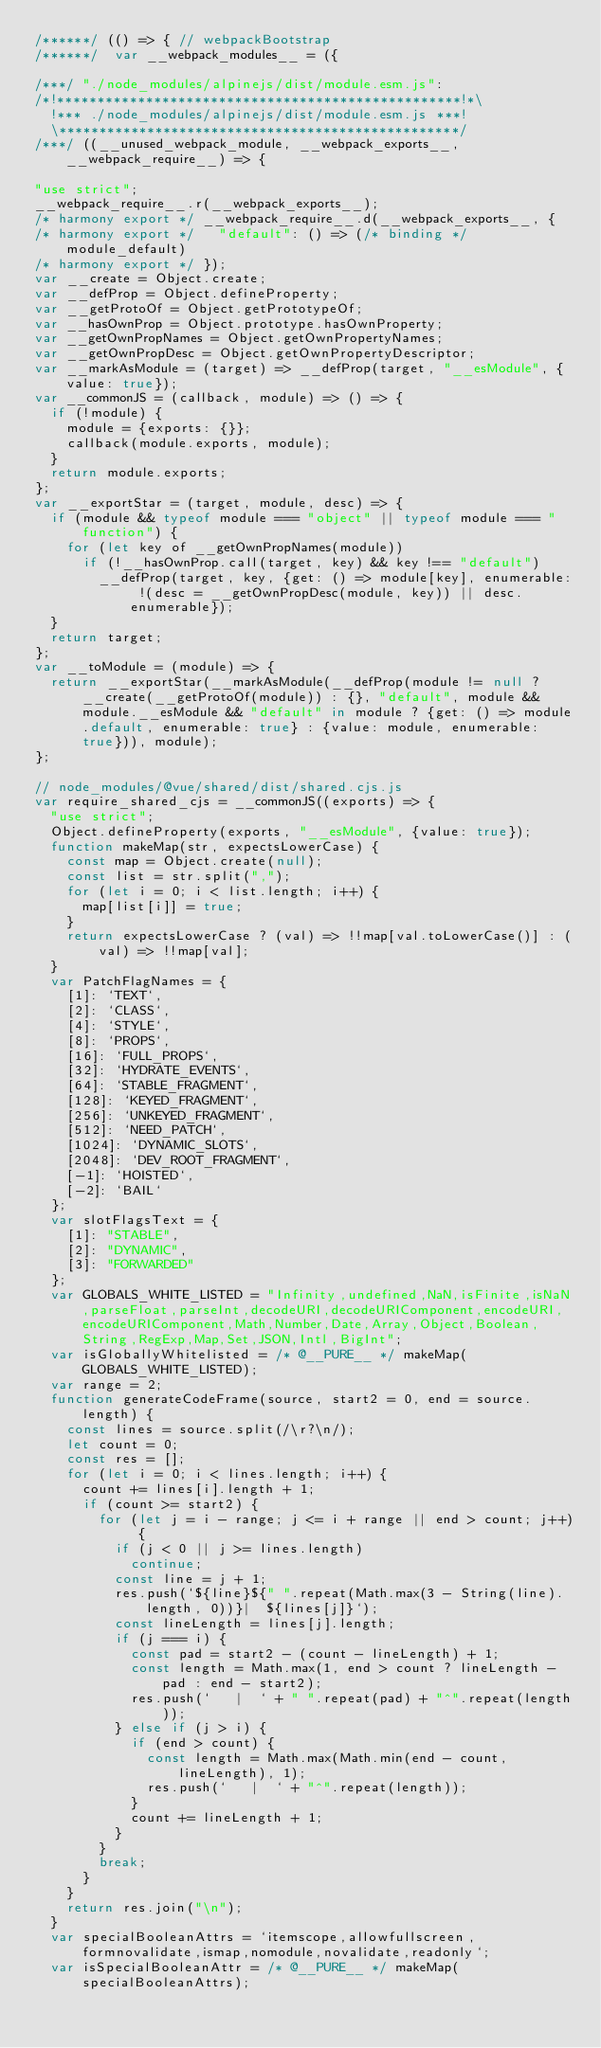Convert code to text. <code><loc_0><loc_0><loc_500><loc_500><_JavaScript_>/******/ (() => { // webpackBootstrap
/******/ 	var __webpack_modules__ = ({

/***/ "./node_modules/alpinejs/dist/module.esm.js":
/*!**************************************************!*\
  !*** ./node_modules/alpinejs/dist/module.esm.js ***!
  \**************************************************/
/***/ ((__unused_webpack_module, __webpack_exports__, __webpack_require__) => {

"use strict";
__webpack_require__.r(__webpack_exports__);
/* harmony export */ __webpack_require__.d(__webpack_exports__, {
/* harmony export */   "default": () => (/* binding */ module_default)
/* harmony export */ });
var __create = Object.create;
var __defProp = Object.defineProperty;
var __getProtoOf = Object.getPrototypeOf;
var __hasOwnProp = Object.prototype.hasOwnProperty;
var __getOwnPropNames = Object.getOwnPropertyNames;
var __getOwnPropDesc = Object.getOwnPropertyDescriptor;
var __markAsModule = (target) => __defProp(target, "__esModule", {value: true});
var __commonJS = (callback, module) => () => {
  if (!module) {
    module = {exports: {}};
    callback(module.exports, module);
  }
  return module.exports;
};
var __exportStar = (target, module, desc) => {
  if (module && typeof module === "object" || typeof module === "function") {
    for (let key of __getOwnPropNames(module))
      if (!__hasOwnProp.call(target, key) && key !== "default")
        __defProp(target, key, {get: () => module[key], enumerable: !(desc = __getOwnPropDesc(module, key)) || desc.enumerable});
  }
  return target;
};
var __toModule = (module) => {
  return __exportStar(__markAsModule(__defProp(module != null ? __create(__getProtoOf(module)) : {}, "default", module && module.__esModule && "default" in module ? {get: () => module.default, enumerable: true} : {value: module, enumerable: true})), module);
};

// node_modules/@vue/shared/dist/shared.cjs.js
var require_shared_cjs = __commonJS((exports) => {
  "use strict";
  Object.defineProperty(exports, "__esModule", {value: true});
  function makeMap(str, expectsLowerCase) {
    const map = Object.create(null);
    const list = str.split(",");
    for (let i = 0; i < list.length; i++) {
      map[list[i]] = true;
    }
    return expectsLowerCase ? (val) => !!map[val.toLowerCase()] : (val) => !!map[val];
  }
  var PatchFlagNames = {
    [1]: `TEXT`,
    [2]: `CLASS`,
    [4]: `STYLE`,
    [8]: `PROPS`,
    [16]: `FULL_PROPS`,
    [32]: `HYDRATE_EVENTS`,
    [64]: `STABLE_FRAGMENT`,
    [128]: `KEYED_FRAGMENT`,
    [256]: `UNKEYED_FRAGMENT`,
    [512]: `NEED_PATCH`,
    [1024]: `DYNAMIC_SLOTS`,
    [2048]: `DEV_ROOT_FRAGMENT`,
    [-1]: `HOISTED`,
    [-2]: `BAIL`
  };
  var slotFlagsText = {
    [1]: "STABLE",
    [2]: "DYNAMIC",
    [3]: "FORWARDED"
  };
  var GLOBALS_WHITE_LISTED = "Infinity,undefined,NaN,isFinite,isNaN,parseFloat,parseInt,decodeURI,decodeURIComponent,encodeURI,encodeURIComponent,Math,Number,Date,Array,Object,Boolean,String,RegExp,Map,Set,JSON,Intl,BigInt";
  var isGloballyWhitelisted = /* @__PURE__ */ makeMap(GLOBALS_WHITE_LISTED);
  var range = 2;
  function generateCodeFrame(source, start2 = 0, end = source.length) {
    const lines = source.split(/\r?\n/);
    let count = 0;
    const res = [];
    for (let i = 0; i < lines.length; i++) {
      count += lines[i].length + 1;
      if (count >= start2) {
        for (let j = i - range; j <= i + range || end > count; j++) {
          if (j < 0 || j >= lines.length)
            continue;
          const line = j + 1;
          res.push(`${line}${" ".repeat(Math.max(3 - String(line).length, 0))}|  ${lines[j]}`);
          const lineLength = lines[j].length;
          if (j === i) {
            const pad = start2 - (count - lineLength) + 1;
            const length = Math.max(1, end > count ? lineLength - pad : end - start2);
            res.push(`   |  ` + " ".repeat(pad) + "^".repeat(length));
          } else if (j > i) {
            if (end > count) {
              const length = Math.max(Math.min(end - count, lineLength), 1);
              res.push(`   |  ` + "^".repeat(length));
            }
            count += lineLength + 1;
          }
        }
        break;
      }
    }
    return res.join("\n");
  }
  var specialBooleanAttrs = `itemscope,allowfullscreen,formnovalidate,ismap,nomodule,novalidate,readonly`;
  var isSpecialBooleanAttr = /* @__PURE__ */ makeMap(specialBooleanAttrs);</code> 